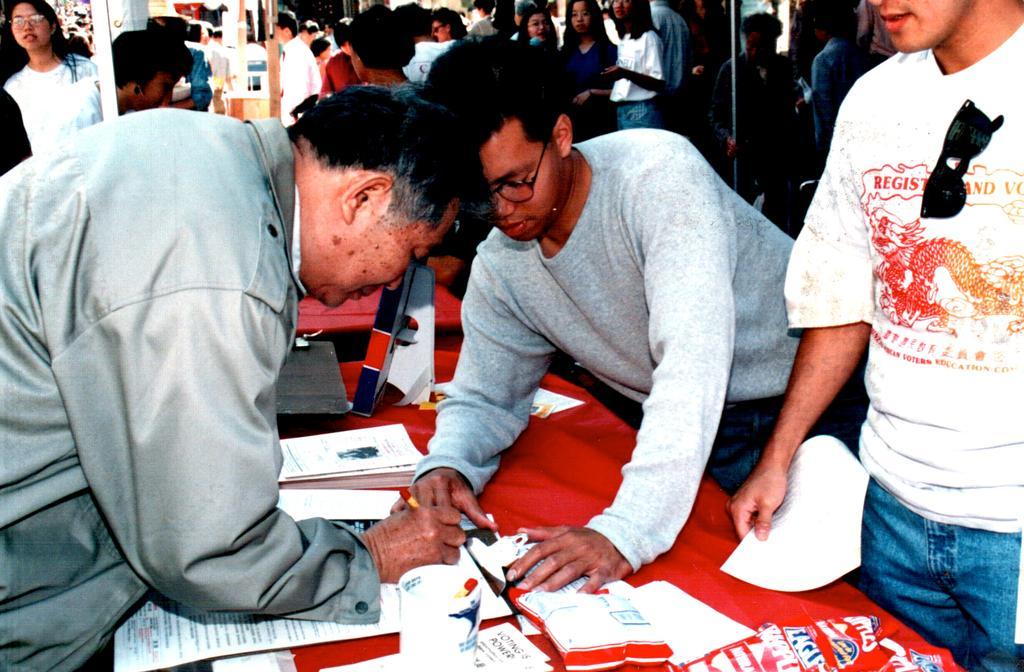How many people are in the image? There is a group of people in the image. What is on the table in the image? There is a table in the image with papers, a glass, and a red color cloth. What might the people be using the table for? The people might be using the table for working or discussing something, as there are papers and a glass visible. Where is the scarecrow located in the image? There is no scarecrow present in the image. What is the opinion of the people in the image about the topic being discussed? The image does not provide any information about the opinions of the people in the image. 